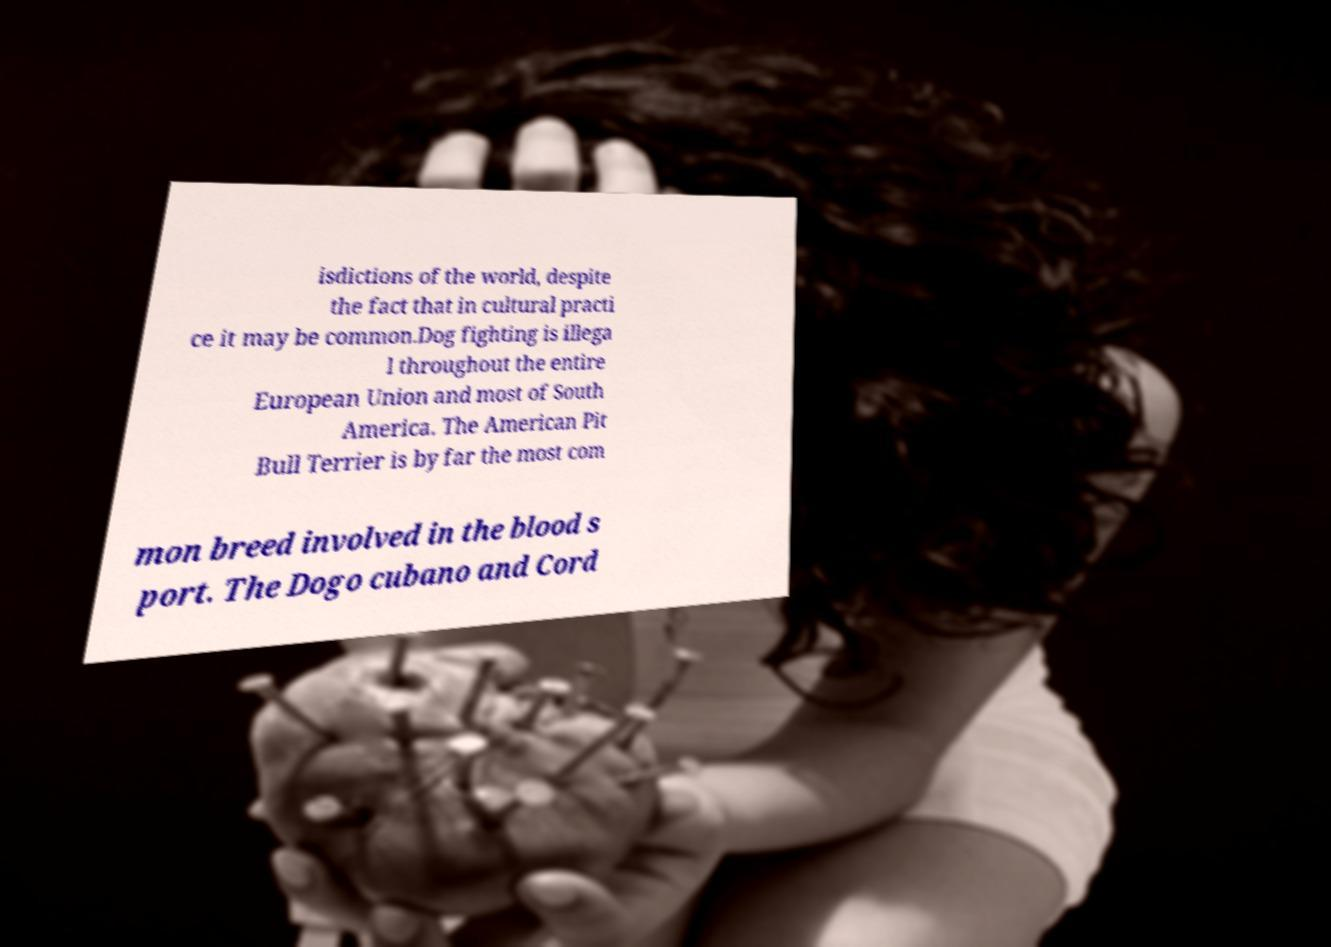Could you extract and type out the text from this image? isdictions of the world, despite the fact that in cultural practi ce it may be common.Dog fighting is illega l throughout the entire European Union and most of South America. The American Pit Bull Terrier is by far the most com mon breed involved in the blood s port. The Dogo cubano and Cord 